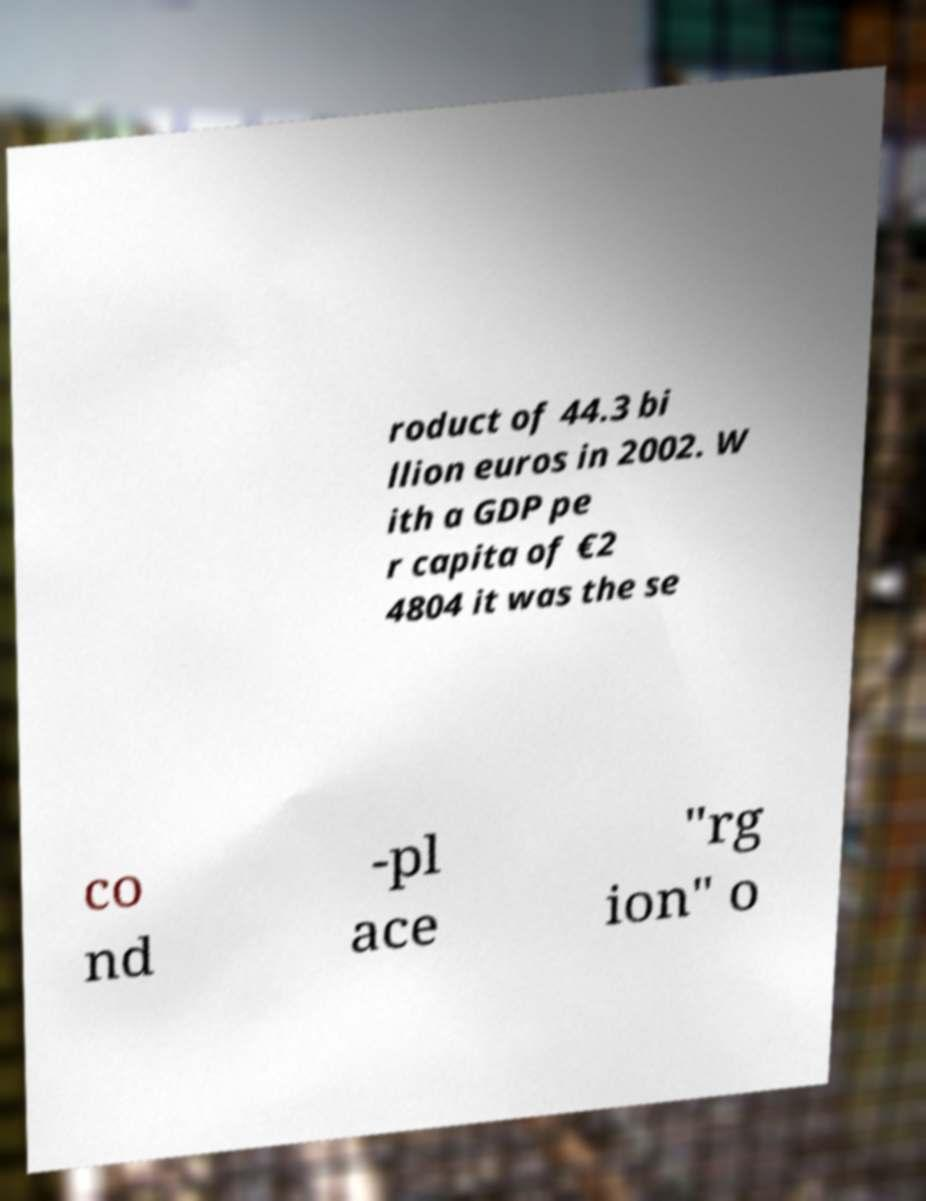Can you read and provide the text displayed in the image?This photo seems to have some interesting text. Can you extract and type it out for me? roduct of 44.3 bi llion euros in 2002. W ith a GDP pe r capita of €2 4804 it was the se co nd -pl ace "rg ion" o 